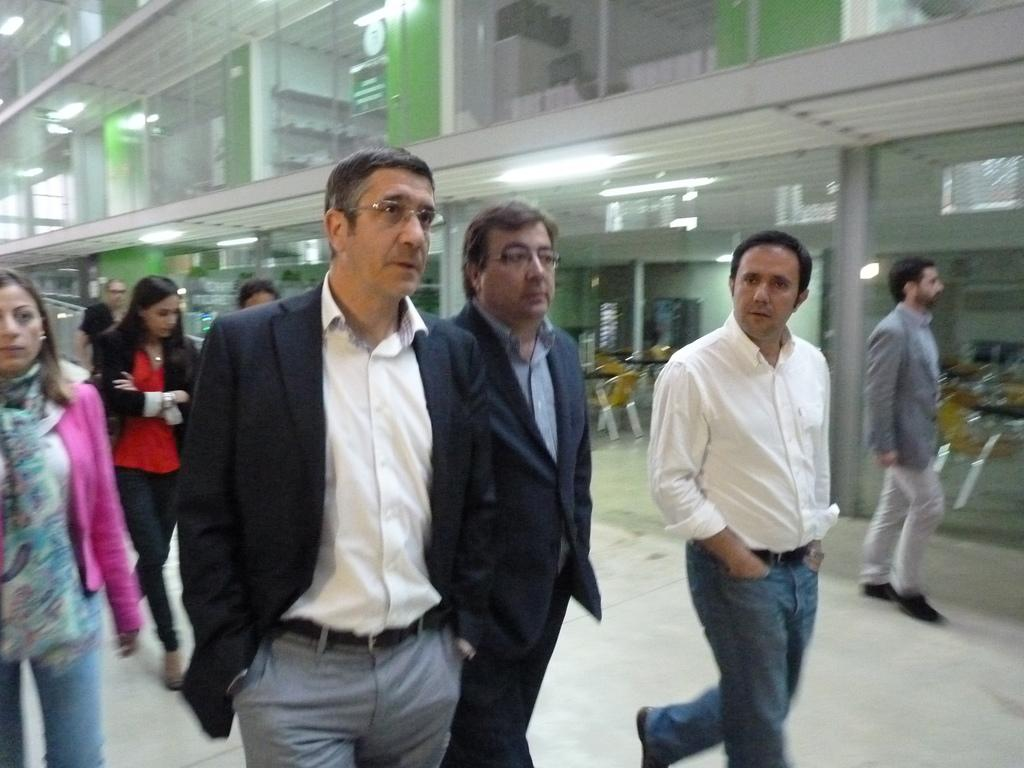Who is present in the image? There are people (men and women) in the image. What are the people doing in the image? The people are walking. What can be seen in the background of the image? There is a building in the image. What type of juice is being served during the argument in the image? There is no argument or juice present in the image; it features people walking and a building in the background. 